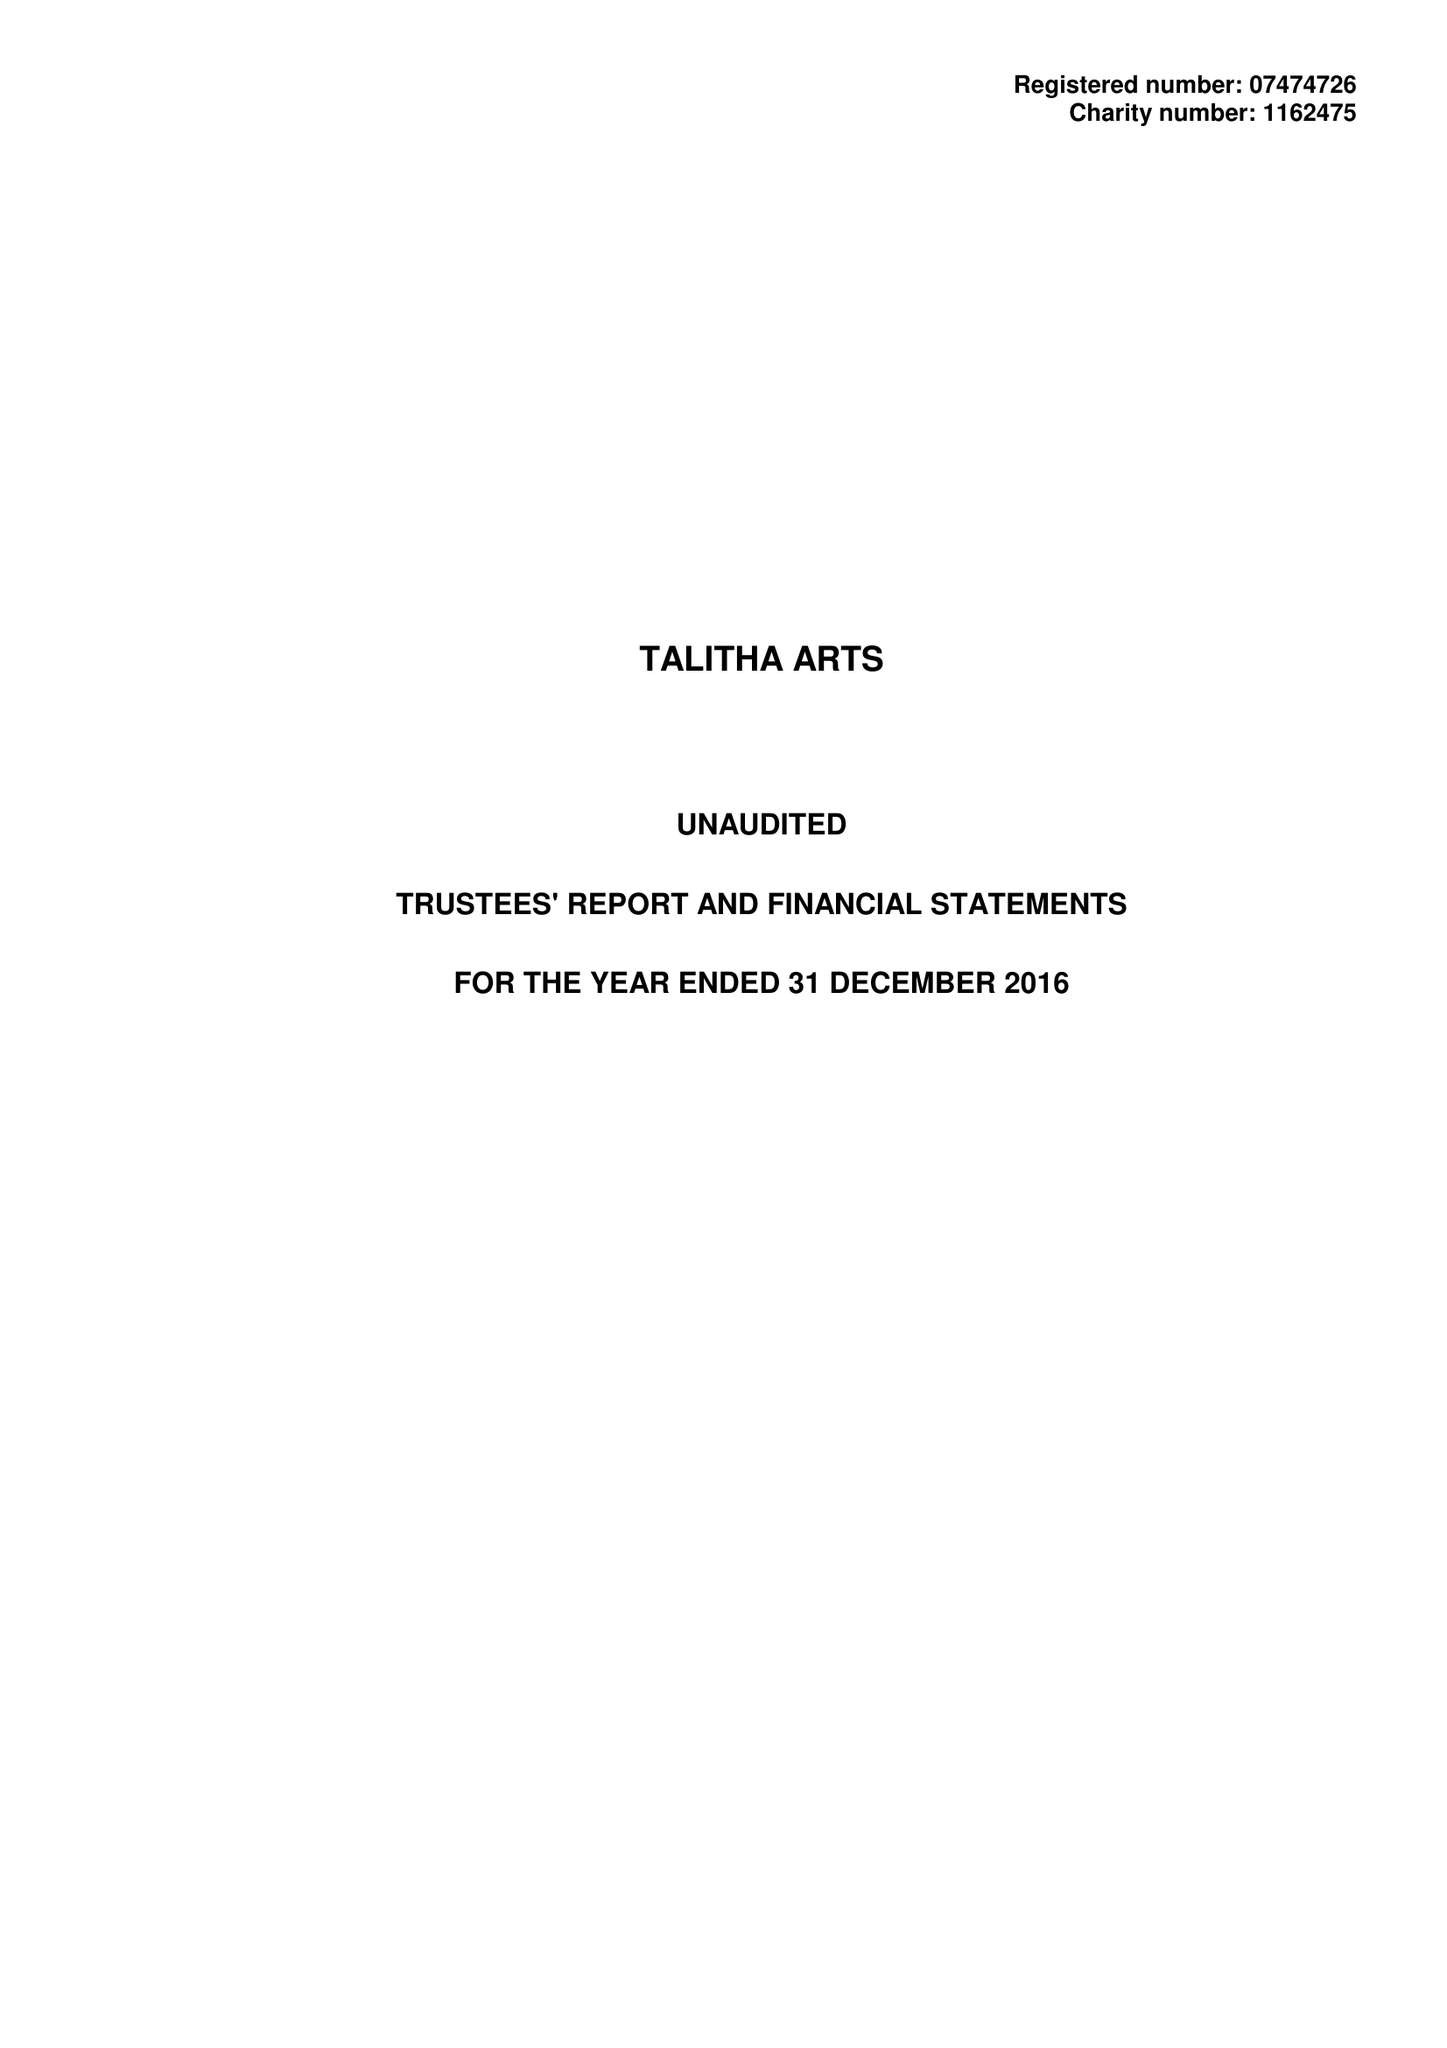What is the value for the charity_name?
Answer the question using a single word or phrase. Talitha Arts 